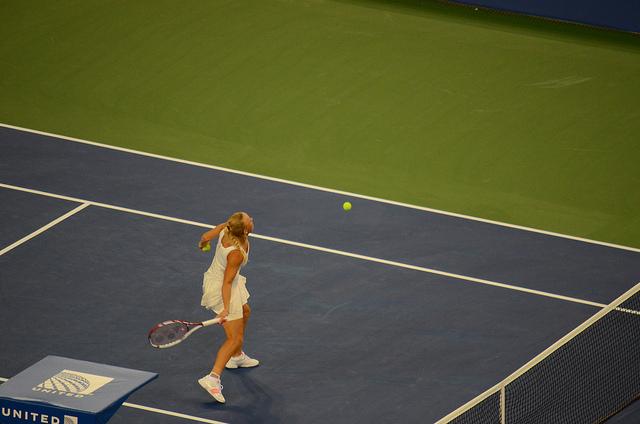Is the woman wearing pants?
Answer briefly. No. Is this person using a tennis uniform?
Quick response, please. Yes. Is the court pristine or roughed up a bit?
Keep it brief. Pristine. What is the woman doing?
Be succinct. Playing tennis. 